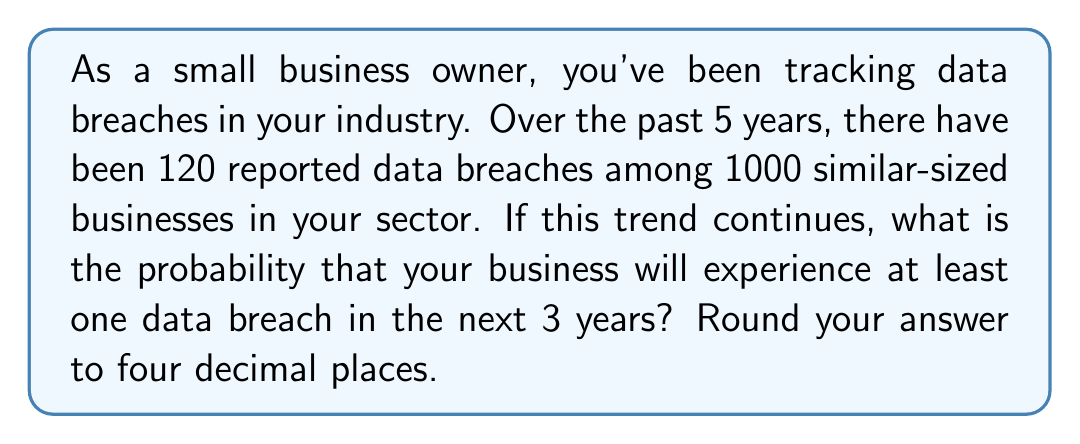Can you solve this math problem? Let's approach this step-by-step:

1) First, we need to calculate the probability of a data breach occurring in a single year:

   $P(\text{breach in 1 year}) = \frac{\text{Number of breaches}}{\text{Number of businesses} \times \text{Number of years}}$

   $P(\text{breach in 1 year}) = \frac{120}{1000 \times 5} = 0.024$ or 2.4%

2) Now, we need to find the probability of no breach occurring in one year:

   $P(\text{no breach in 1 year}) = 1 - P(\text{breach in 1 year}) = 1 - 0.024 = 0.976$ or 97.6%

3) For three years, we need the probability of no breach occurring for three consecutive years:

   $P(\text{no breach in 3 years}) = (0.976)^3 = 0.9292$ or 92.92%

4) Finally, the probability of at least one breach in 3 years is the complement of no breach occurring:

   $P(\text{at least one breach in 3 years}) = 1 - P(\text{no breach in 3 years})$
   
   $= 1 - 0.9292 = 0.0708$

5) Rounding to four decimal places:

   $0.0708 \approx 0.0708$
Answer: $0.0708$ or $7.08\%$ 